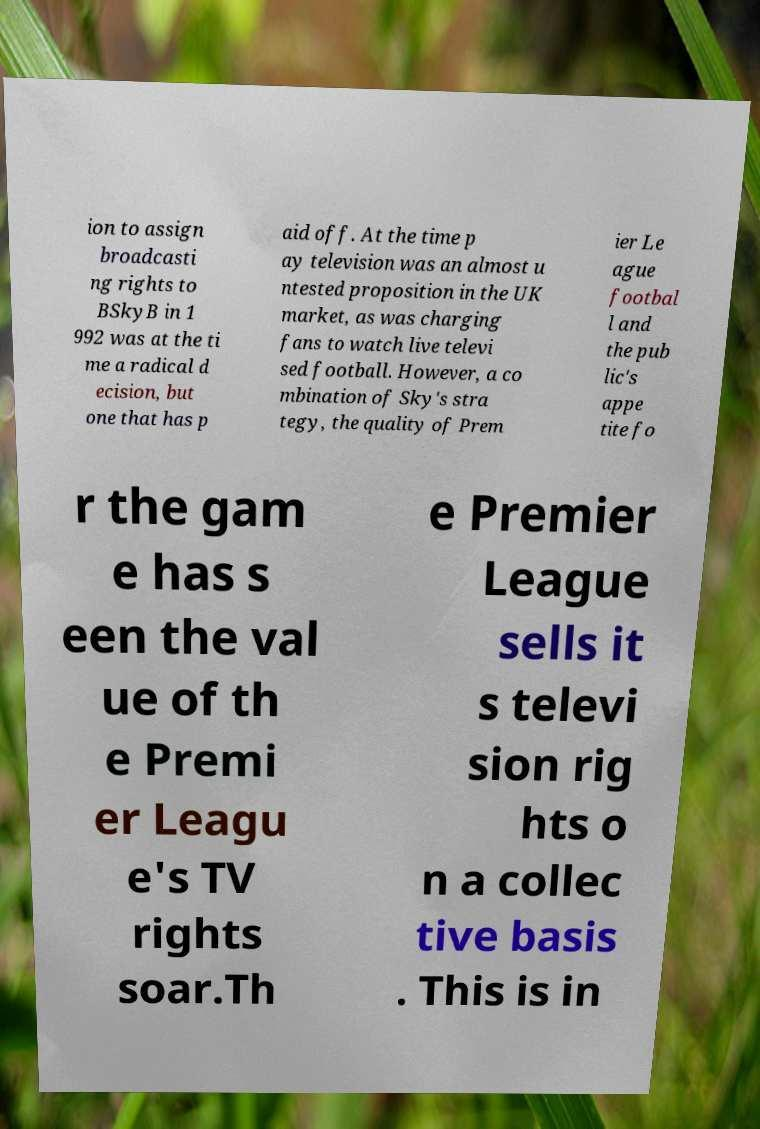Can you accurately transcribe the text from the provided image for me? ion to assign broadcasti ng rights to BSkyB in 1 992 was at the ti me a radical d ecision, but one that has p aid off. At the time p ay television was an almost u ntested proposition in the UK market, as was charging fans to watch live televi sed football. However, a co mbination of Sky's stra tegy, the quality of Prem ier Le ague footbal l and the pub lic's appe tite fo r the gam e has s een the val ue of th e Premi er Leagu e's TV rights soar.Th e Premier League sells it s televi sion rig hts o n a collec tive basis . This is in 